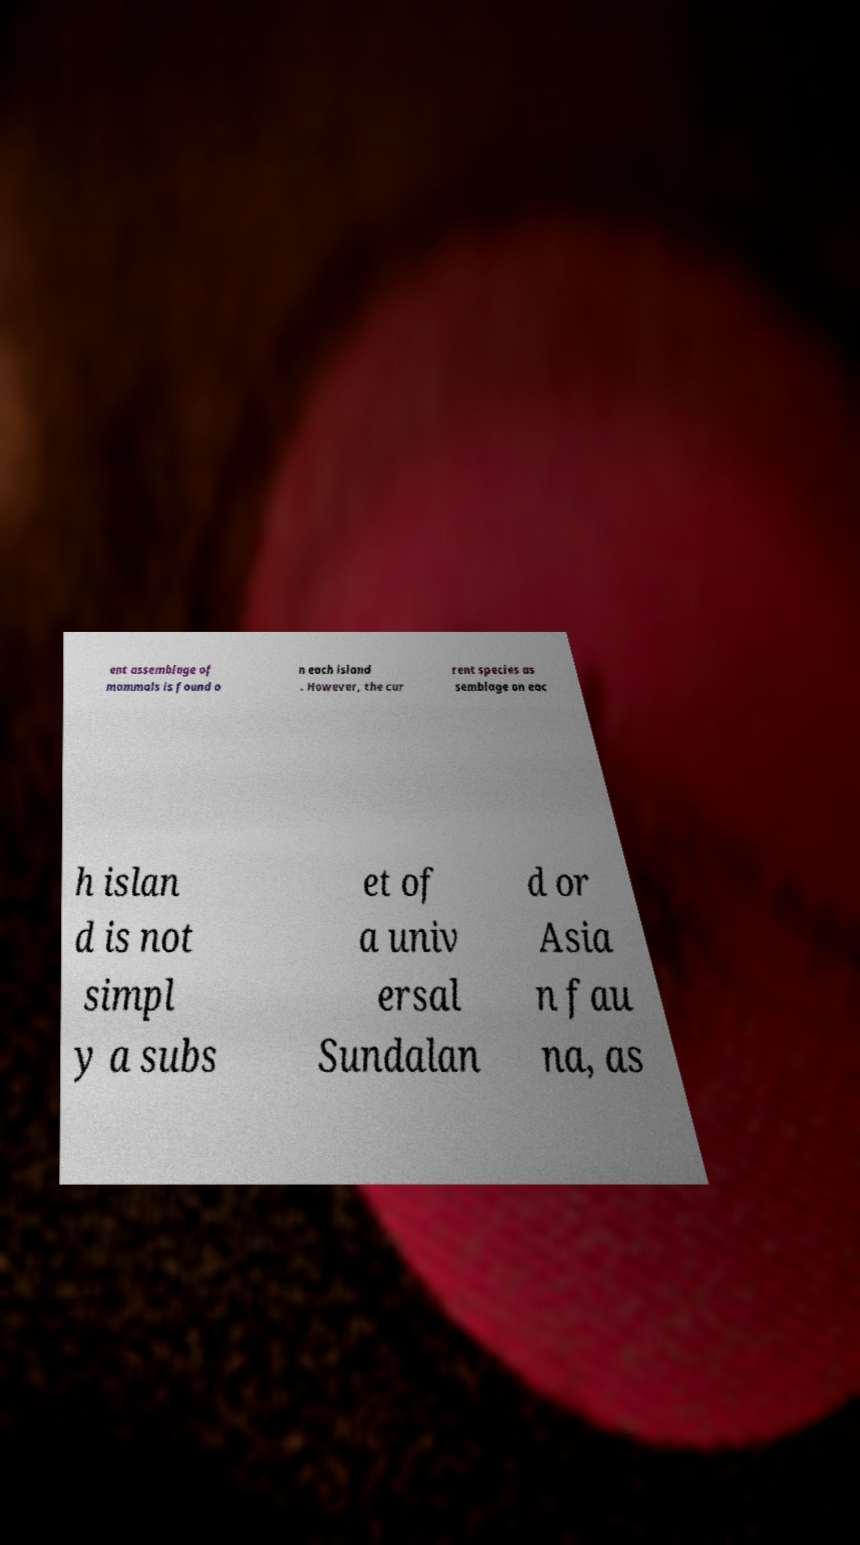Can you read and provide the text displayed in the image?This photo seems to have some interesting text. Can you extract and type it out for me? ent assemblage of mammals is found o n each island . However, the cur rent species as semblage on eac h islan d is not simpl y a subs et of a univ ersal Sundalan d or Asia n fau na, as 